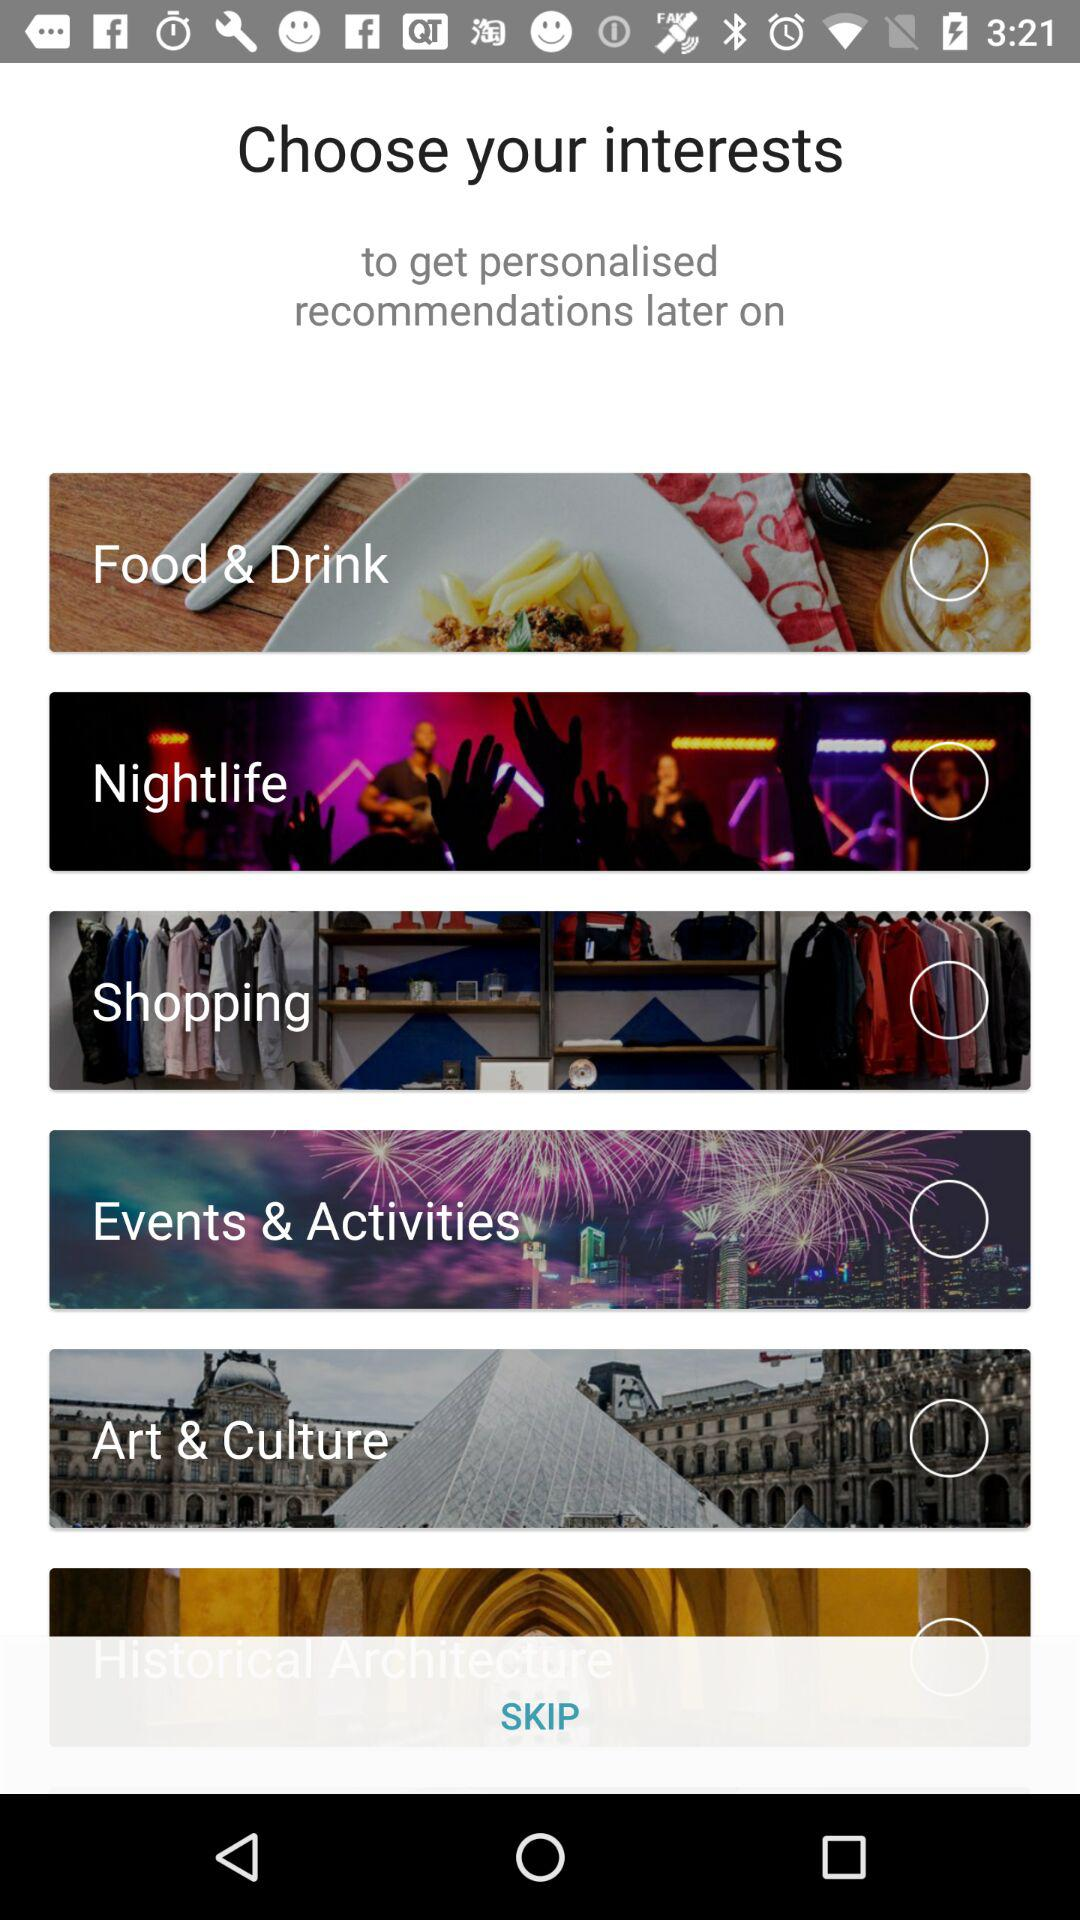What are the options for choosing interests? The options are "Food & Drink", "Android Beam", "Shopping", "Events & Activities" and "Art & Culture". 